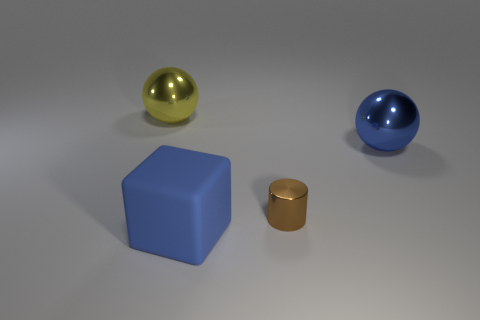Is there a big object of the same color as the cube?
Your response must be concise. Yes. There is a big rubber thing; is it the same color as the shiny sphere right of the big yellow shiny object?
Make the answer very short. Yes. There is a sphere that is the same color as the big rubber thing; what is it made of?
Offer a terse response. Metal. Is there anything else that is the same shape as the matte object?
Ensure brevity in your answer.  No. Are there fewer large blocks than small brown blocks?
Make the answer very short. No. Is there any other thing that has the same size as the brown metallic cylinder?
Give a very brief answer. No. Are there more small metal cylinders than yellow rubber objects?
Make the answer very short. Yes. What number of other things are there of the same color as the big matte thing?
Give a very brief answer. 1. There is a large blue thing behind the brown metal object; what number of large balls are left of it?
Make the answer very short. 1. There is a rubber cube; are there any big shiny balls right of it?
Offer a very short reply. Yes. 